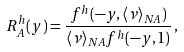Convert formula to latex. <formula><loc_0><loc_0><loc_500><loc_500>R ^ { h } _ { A } ( y ) = \frac { f ^ { h } ( - y , \langle \nu \rangle _ { N A } ) } { \langle \nu \rangle _ { N A } f ^ { h } ( - y , 1 ) } \, ,</formula> 